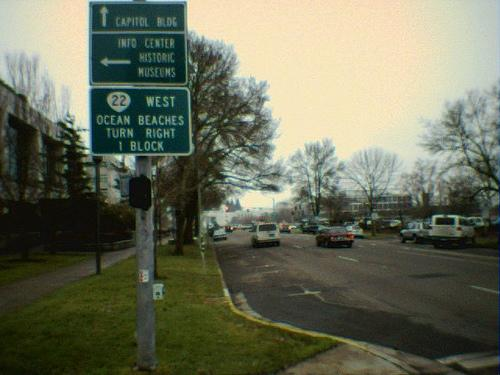What type of signs are these?

Choices:
A) directional
B) warning
C) brand
D) regulatory directional 